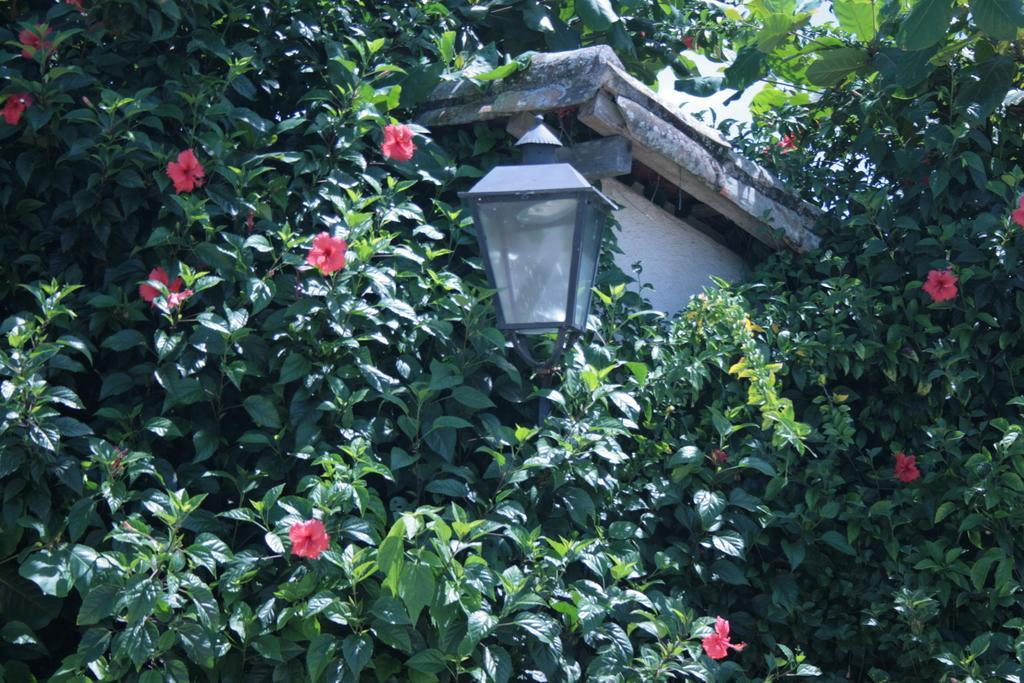How would you summarize this image in a sentence or two? In this image, we can see plants with green leaves and there are also flowers which are red in color and there is also a light pole in between the plants. 